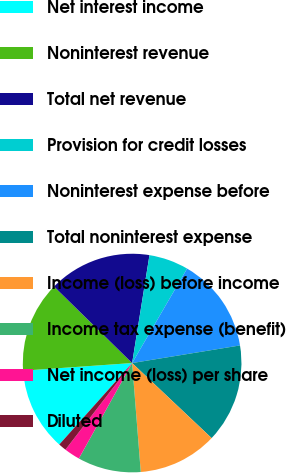<chart> <loc_0><loc_0><loc_500><loc_500><pie_chart><fcel>Net interest income<fcel>Noninterest revenue<fcel>Total net revenue<fcel>Provision for credit losses<fcel>Noninterest expense before<fcel>Total noninterest expense<fcel>Income (loss) before income<fcel>Income tax expense (benefit)<fcel>Net income (loss) per share<fcel>Diluted<nl><fcel>12.28%<fcel>13.45%<fcel>15.2%<fcel>5.85%<fcel>14.04%<fcel>14.62%<fcel>11.7%<fcel>9.36%<fcel>2.34%<fcel>1.17%<nl></chart> 